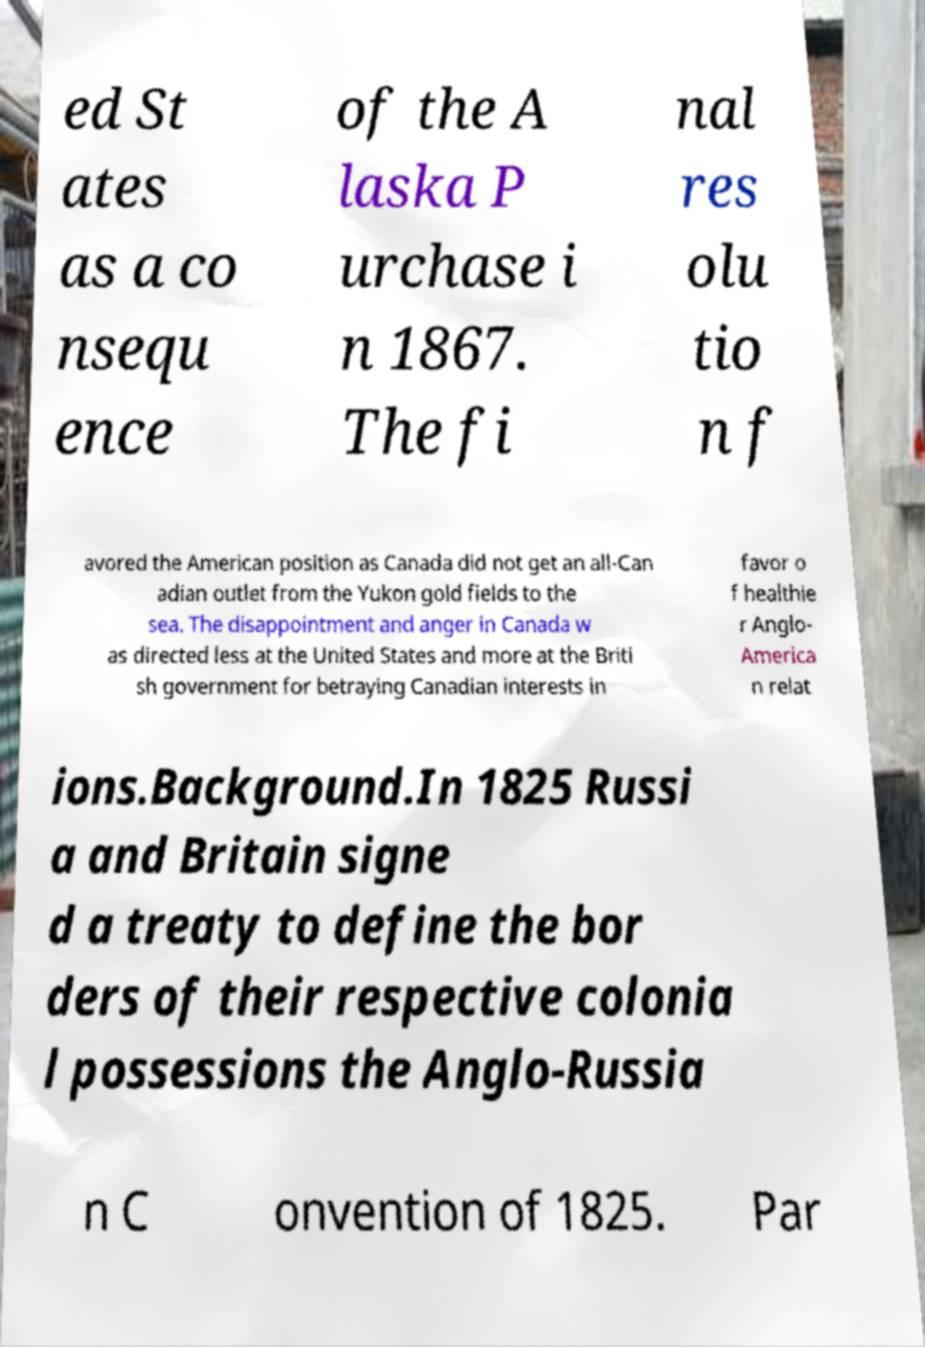There's text embedded in this image that I need extracted. Can you transcribe it verbatim? ed St ates as a co nsequ ence of the A laska P urchase i n 1867. The fi nal res olu tio n f avored the American position as Canada did not get an all-Can adian outlet from the Yukon gold fields to the sea. The disappointment and anger in Canada w as directed less at the United States and more at the Briti sh government for betraying Canadian interests in favor o f healthie r Anglo- America n relat ions.Background.In 1825 Russi a and Britain signe d a treaty to define the bor ders of their respective colonia l possessions the Anglo-Russia n C onvention of 1825. Par 